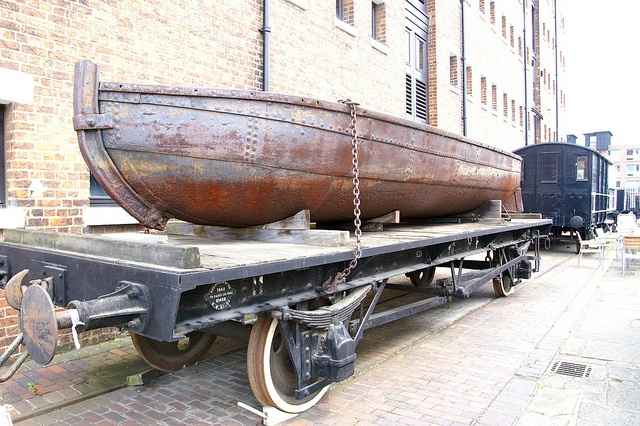Describe the objects in this image and their specific colors. I can see train in darkgray, gray, black, and lightgray tones, boat in darkgray, lightgray, maroon, and gray tones, chair in darkgray, white, gray, and lavender tones, chair in darkgray, lightgray, and tan tones, and chair in darkgray, white, purple, and lavender tones in this image. 